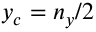<formula> <loc_0><loc_0><loc_500><loc_500>y _ { c } = n _ { y } / 2</formula> 